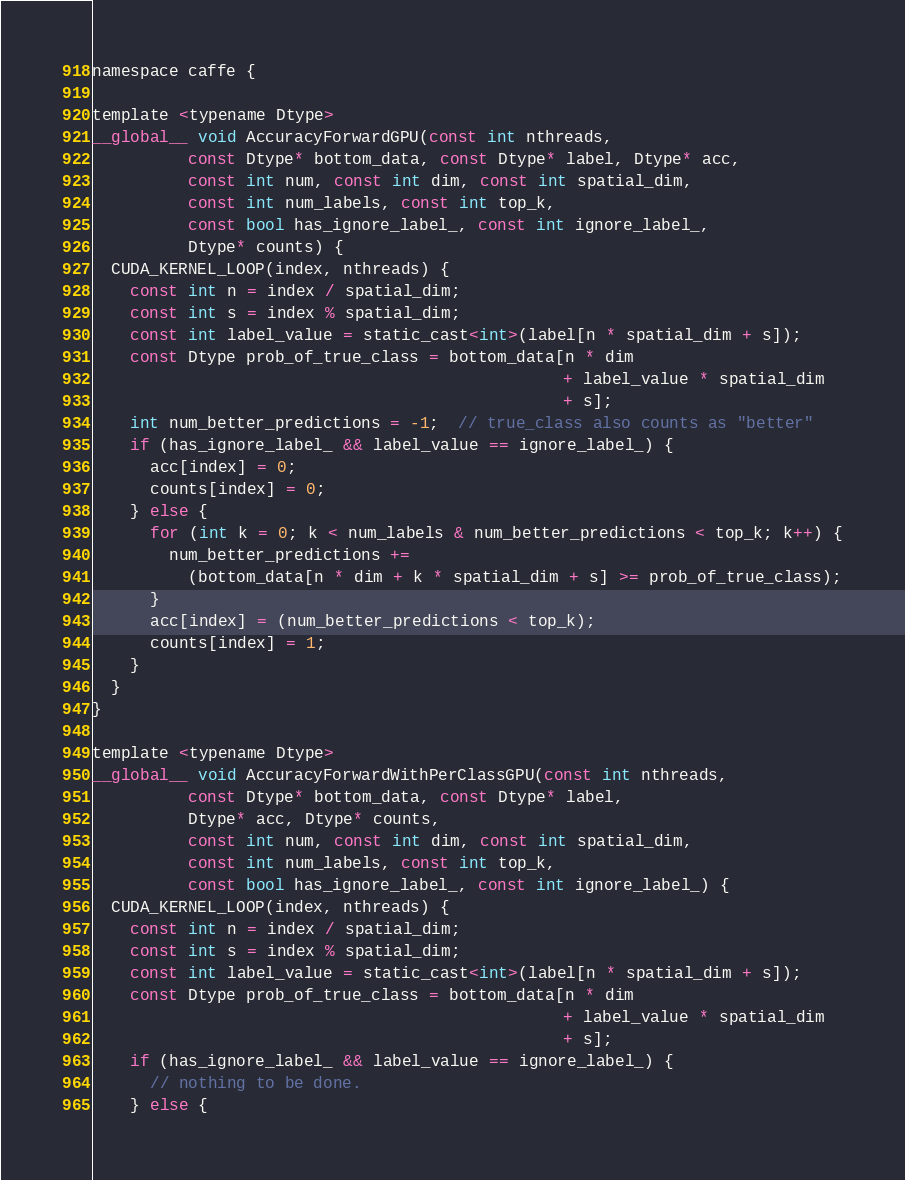<code> <loc_0><loc_0><loc_500><loc_500><_Cuda_>
namespace caffe {

template <typename Dtype>
__global__ void AccuracyForwardGPU(const int nthreads,
          const Dtype* bottom_data, const Dtype* label, Dtype* acc,
          const int num, const int dim, const int spatial_dim,
          const int num_labels, const int top_k,
          const bool has_ignore_label_, const int ignore_label_,
          Dtype* counts) {
  CUDA_KERNEL_LOOP(index, nthreads) {
    const int n = index / spatial_dim;
    const int s = index % spatial_dim;
    const int label_value = static_cast<int>(label[n * spatial_dim + s]);
    const Dtype prob_of_true_class = bottom_data[n * dim
                                                 + label_value * spatial_dim
                                                 + s];
    int num_better_predictions = -1;  // true_class also counts as "better"
    if (has_ignore_label_ && label_value == ignore_label_) {
      acc[index] = 0;
      counts[index] = 0;
    } else {
      for (int k = 0; k < num_labels & num_better_predictions < top_k; k++) {
        num_better_predictions +=
          (bottom_data[n * dim + k * spatial_dim + s] >= prob_of_true_class);
      }
      acc[index] = (num_better_predictions < top_k);
      counts[index] = 1;
    }
  }
}

template <typename Dtype>
__global__ void AccuracyForwardWithPerClassGPU(const int nthreads,
          const Dtype* bottom_data, const Dtype* label,
          Dtype* acc, Dtype* counts,
          const int num, const int dim, const int spatial_dim,
          const int num_labels, const int top_k,
          const bool has_ignore_label_, const int ignore_label_) {
  CUDA_KERNEL_LOOP(index, nthreads) {
    const int n = index / spatial_dim;
    const int s = index % spatial_dim;
    const int label_value = static_cast<int>(label[n * spatial_dim + s]);
    const Dtype prob_of_true_class = bottom_data[n * dim
                                                 + label_value * spatial_dim
                                                 + s];
    if (has_ignore_label_ && label_value == ignore_label_) {
      // nothing to be done.
    } else {</code> 